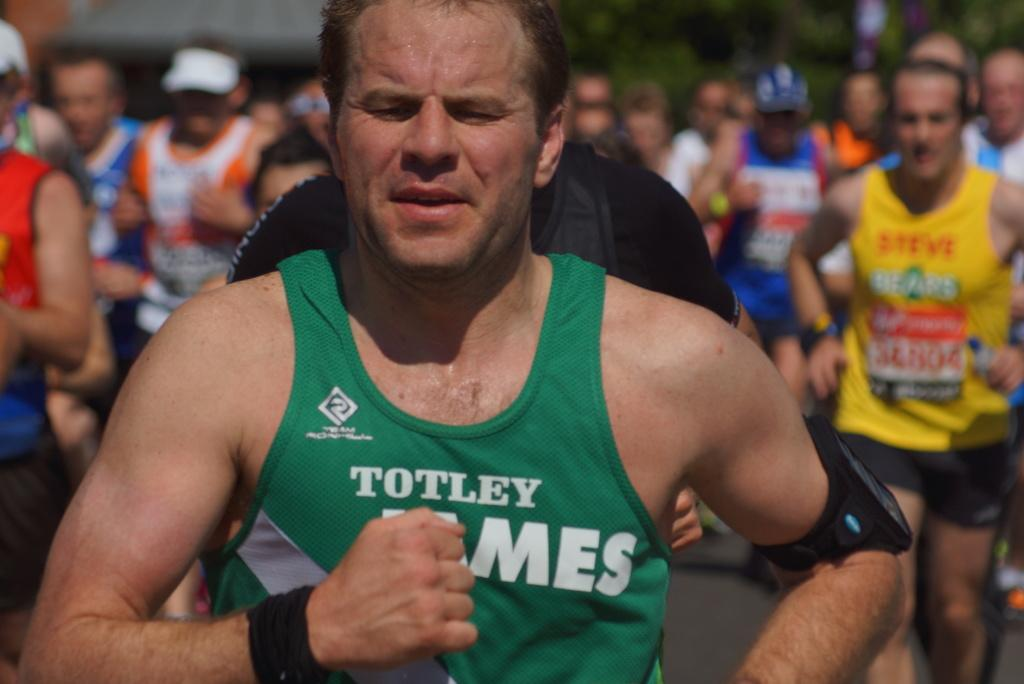What is happening in the image? There are people in the image, and they are running on the road. Can you describe the background of the image? The background of the image is blurry. What type of hat is the person wearing while sitting on the chair in the image? There is no person wearing a hat or sitting on a chair in the image; the people are running on the road. 